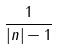<formula> <loc_0><loc_0><loc_500><loc_500>\frac { 1 } { | n | - 1 }</formula> 